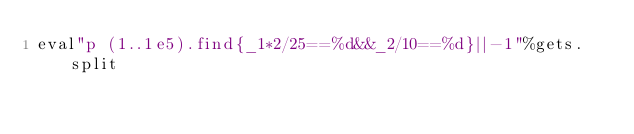<code> <loc_0><loc_0><loc_500><loc_500><_Ruby_>eval"p (1..1e5).find{_1*2/25==%d&&_2/10==%d}||-1"%gets.split</code> 